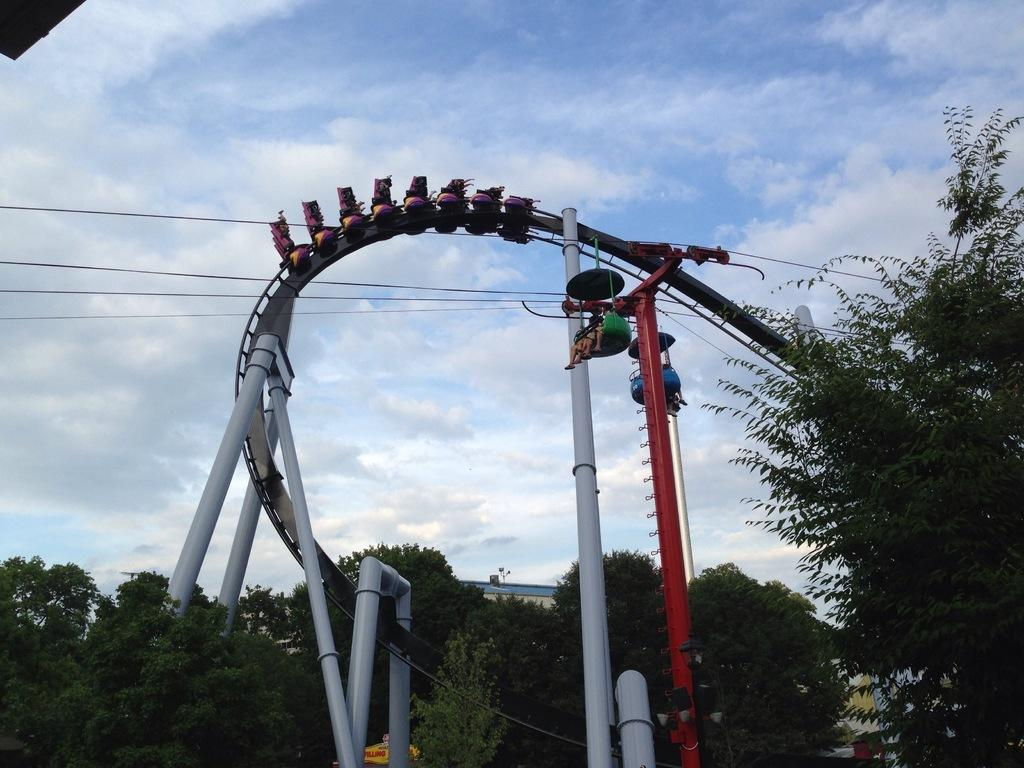What are the main subjects in the image? There are two mechanical rides in the image. What type of natural elements can be seen in the image? There are trees in the image. What else is present in the image besides the mechanical rides and trees? There are wires in the image. What is visible in the background of the image? The sky is visible in the background of the image. What type of pin can be seen holding up the mechanical ride in the image? There is no pin present in the image; the mechanical rides are supported by their structures. What time is it according to the watch in the image? There is no watch present in the image. 